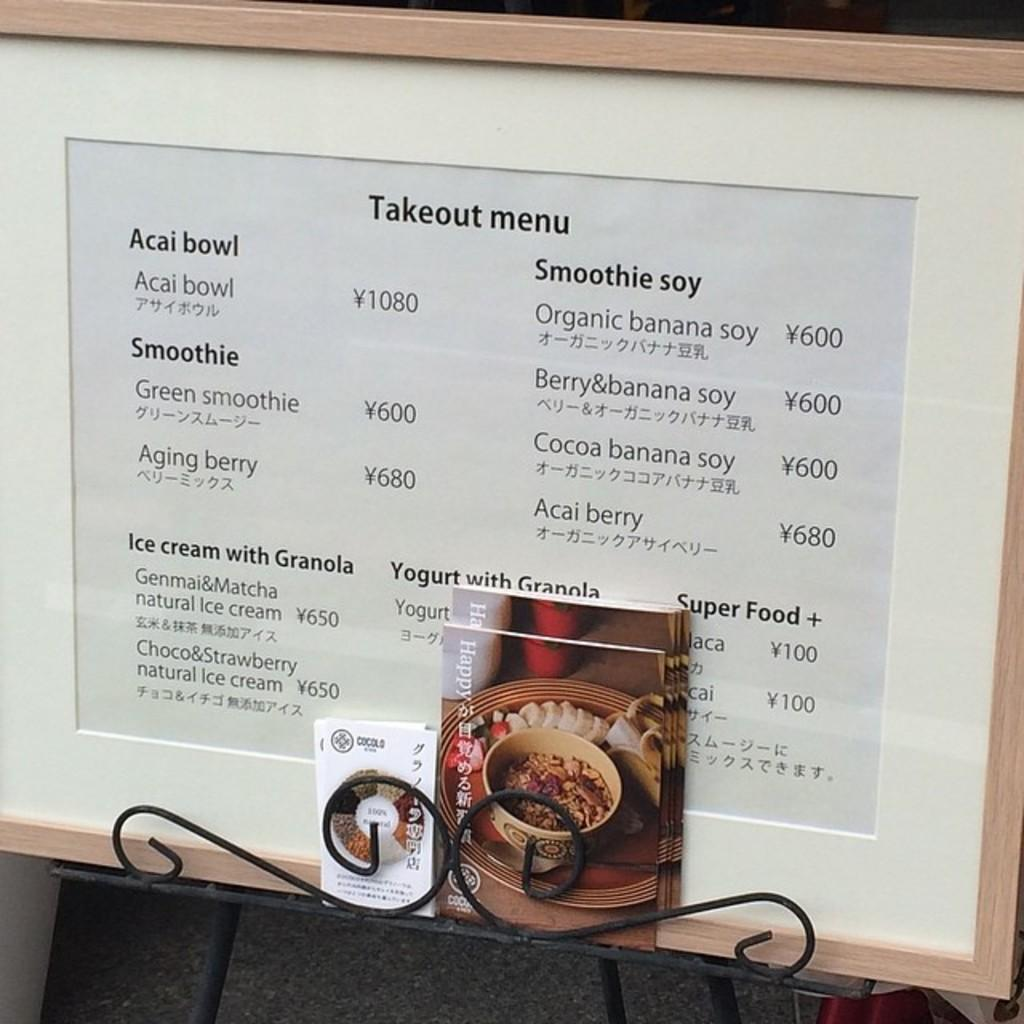What objects are present on the table in the image? There are books and a frame on the table in the image. Can you describe the frame in the image? The frame is a separate object in the image, but its specific characteristics are not mentioned in the provided facts. What is the primary purpose of the books in the image? The primary purpose of the books in the image is not explicitly stated, but they are likely meant for reading or reference. What type of amusement can be seen in the image? There is no amusement present in the image; it features books and a frame on a table. Is there any driving activity taking place in the image? There is no driving activity present in the image. 